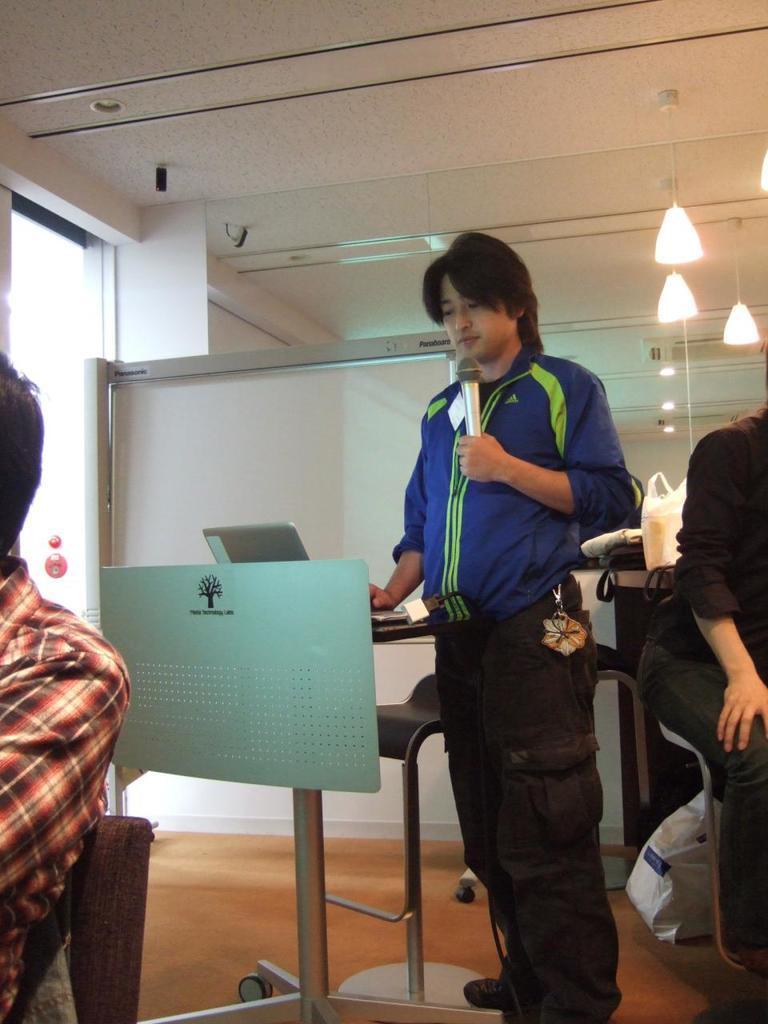Describe this image in one or two sentences. This person standing and holding microphone,these two persons are sitting on the chairs. Behind this person we can see lights,wall,board,cover,bag and object on the table. we can see cover on the floor. We can see laptop on the table. 